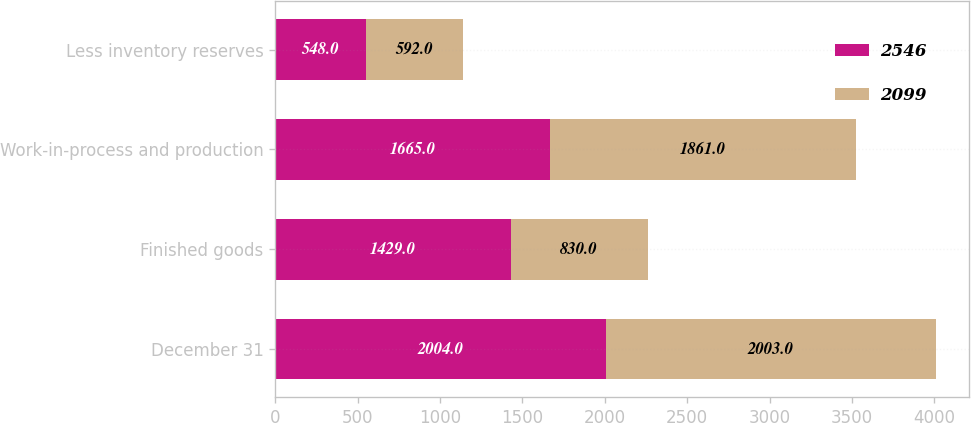Convert chart to OTSL. <chart><loc_0><loc_0><loc_500><loc_500><stacked_bar_chart><ecel><fcel>December 31<fcel>Finished goods<fcel>Work-in-process and production<fcel>Less inventory reserves<nl><fcel>2546<fcel>2004<fcel>1429<fcel>1665<fcel>548<nl><fcel>2099<fcel>2003<fcel>830<fcel>1861<fcel>592<nl></chart> 